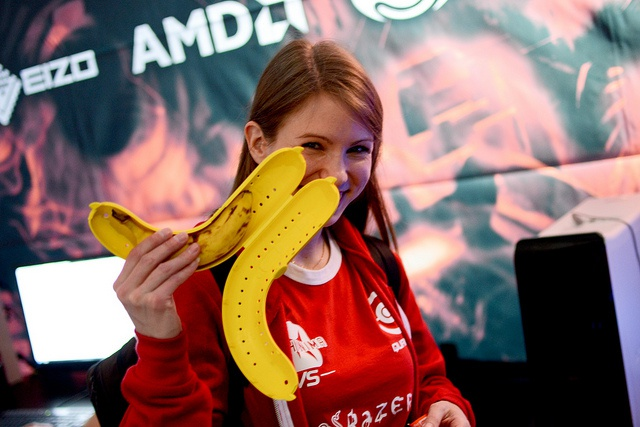Describe the objects in this image and their specific colors. I can see people in black, maroon, and brown tones, laptop in black, white, lightblue, and salmon tones, and banana in black, olive, orange, and maroon tones in this image. 